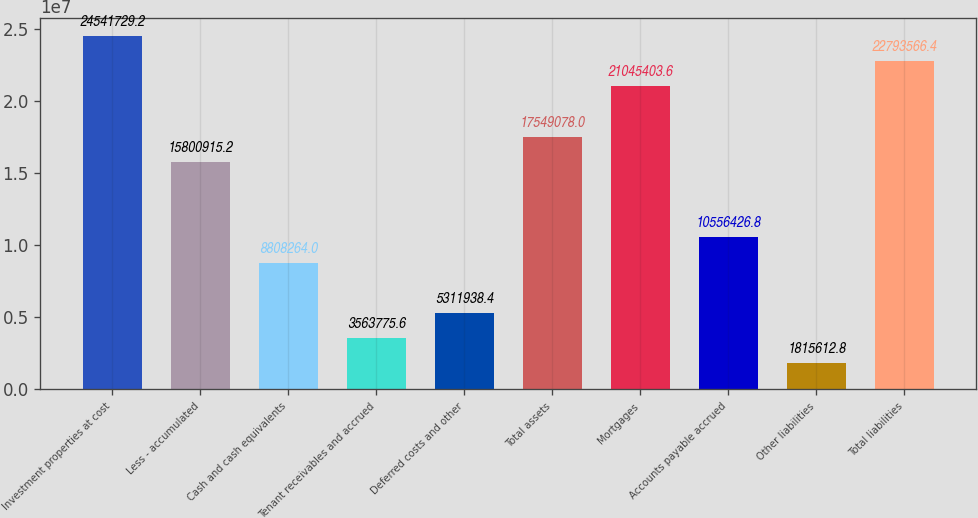Convert chart. <chart><loc_0><loc_0><loc_500><loc_500><bar_chart><fcel>Investment properties at cost<fcel>Less - accumulated<fcel>Cash and cash equivalents<fcel>Tenant receivables and accrued<fcel>Deferred costs and other<fcel>Total assets<fcel>Mortgages<fcel>Accounts payable accrued<fcel>Other liabilities<fcel>Total liabilities<nl><fcel>2.45417e+07<fcel>1.58009e+07<fcel>8.80826e+06<fcel>3.56378e+06<fcel>5.31194e+06<fcel>1.75491e+07<fcel>2.10454e+07<fcel>1.05564e+07<fcel>1.81561e+06<fcel>2.27936e+07<nl></chart> 